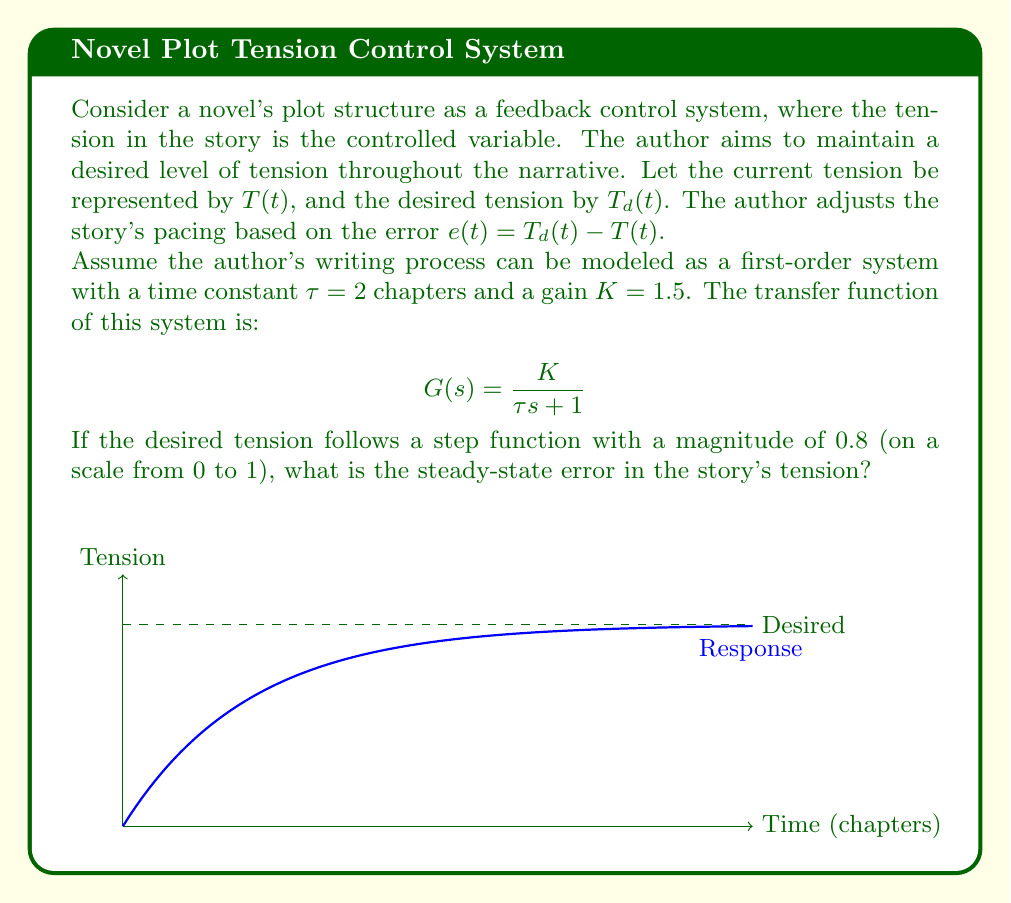Teach me how to tackle this problem. To solve this problem, we'll follow these steps:

1) First, recall that for a first-order system, the steady-state error for a step input is given by:

   $$e_{ss} = \frac{1}{1 + K_p}$$

   where $K_p$ is the position error constant.

2) For our system, we need to find $K_p$. The position error constant is defined as:

   $$K_p = \lim_{s \to 0} sG(s)$$

3) Substituting our transfer function:

   $$K_p = \lim_{s \to 0} s \cdot \frac{K}{\tau s + 1}$$

4) Simplifying:

   $$K_p = \lim_{s \to 0} \frac{sK}{\tau s + 1} = \frac{K}{1} = K = 1.5$$

5) Now we can calculate the steady-state error:

   $$e_{ss} = \frac{1}{1 + K_p} = \frac{1}{1 + 1.5} = \frac{1}{2.5} = 0.4$$

6) However, this is the fractional error. To get the actual error, we need to multiply by the input magnitude:

   $$\text{Actual } e_{ss} = 0.4 \cdot 0.8 = 0.32$$

Therefore, the steady-state error in the story's tension is 0.32 on the 0 to 1 scale.
Answer: 0.32 